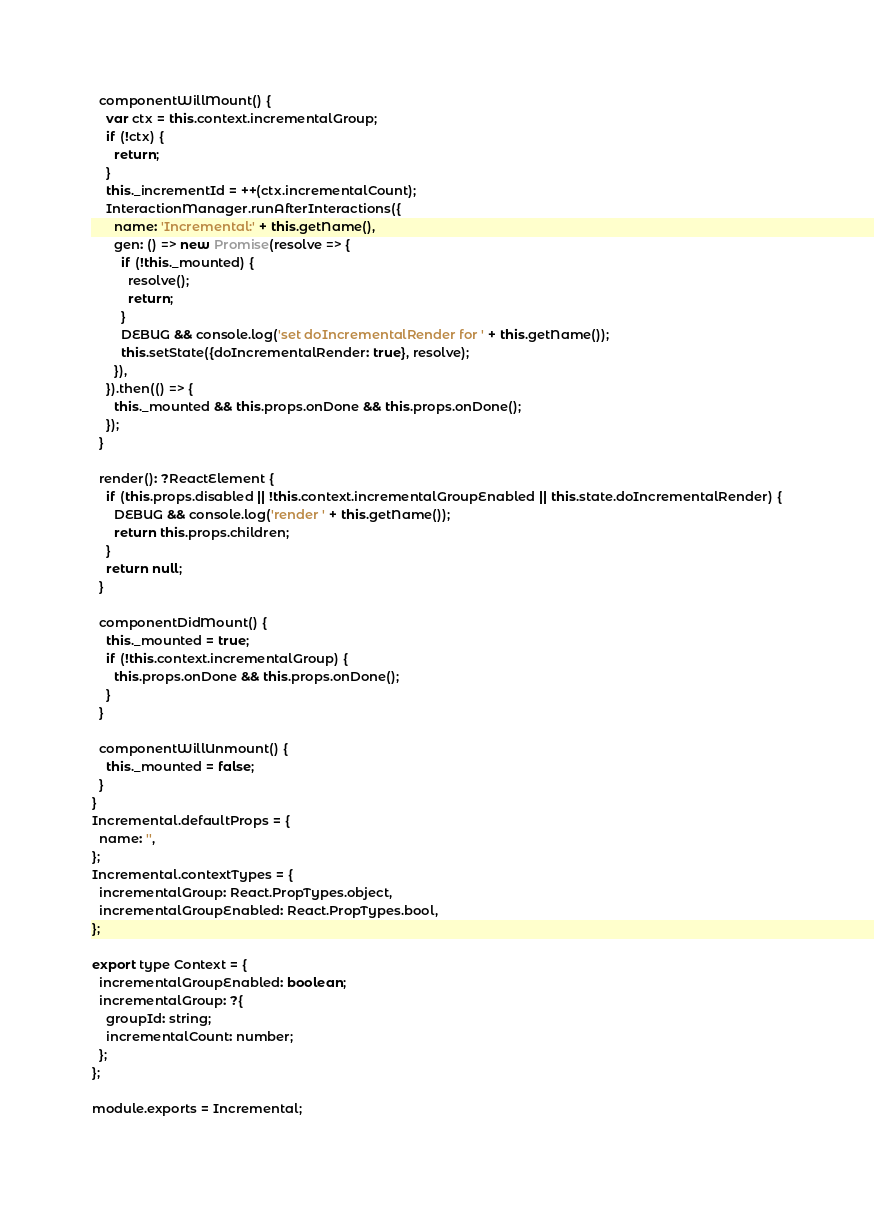Convert code to text. <code><loc_0><loc_0><loc_500><loc_500><_JavaScript_>
  componentWillMount() {
    var ctx = this.context.incrementalGroup;
    if (!ctx) {
      return;
    }
    this._incrementId = ++(ctx.incrementalCount);
    InteractionManager.runAfterInteractions({
      name: 'Incremental:' + this.getName(),
      gen: () => new Promise(resolve => {
        if (!this._mounted) {
          resolve();
          return;
        }
        DEBUG && console.log('set doIncrementalRender for ' + this.getName());
        this.setState({doIncrementalRender: true}, resolve);
      }),
    }).then(() => {
      this._mounted && this.props.onDone && this.props.onDone();
    });
  }

  render(): ?ReactElement {
    if (this.props.disabled || !this.context.incrementalGroupEnabled || this.state.doIncrementalRender) {
      DEBUG && console.log('render ' + this.getName());
      return this.props.children;
    }
    return null;
  }

  componentDidMount() {
    this._mounted = true;
    if (!this.context.incrementalGroup) {
      this.props.onDone && this.props.onDone();
    }
  }

  componentWillUnmount() {
    this._mounted = false;
  }
}
Incremental.defaultProps = {
  name: '',
};
Incremental.contextTypes = {
  incrementalGroup: React.PropTypes.object,
  incrementalGroupEnabled: React.PropTypes.bool,
};

export type Context = {
  incrementalGroupEnabled: boolean;
  incrementalGroup: ?{
    groupId: string;
    incrementalCount: number;
  };
};

module.exports = Incremental;
</code> 